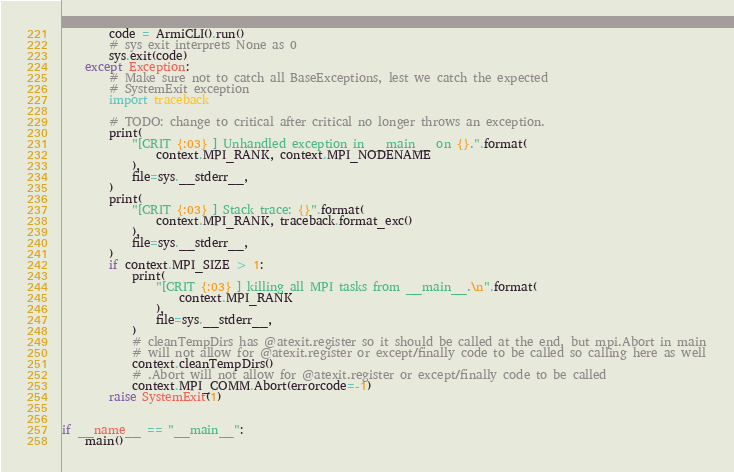<code> <loc_0><loc_0><loc_500><loc_500><_Python_>        code = ArmiCLI().run()
        # sys exit interprets None as 0
        sys.exit(code)
    except Exception:
        # Make sure not to catch all BaseExceptions, lest we catch the expected
        # SystemExit exception
        import traceback

        # TODO: change to critical after critical no longer throws an exception.
        print(
            "[CRIT {:03} ] Unhandled exception in __main__ on {}.".format(
                context.MPI_RANK, context.MPI_NODENAME
            ),
            file=sys.__stderr__,
        )
        print(
            "[CRIT {:03} ] Stack trace: {}".format(
                context.MPI_RANK, traceback.format_exc()
            ),
            file=sys.__stderr__,
        )
        if context.MPI_SIZE > 1:
            print(
                "[CRIT {:03} ] killing all MPI tasks from __main__.\n".format(
                    context.MPI_RANK
                ),
                file=sys.__stderr__,
            )
            # cleanTempDirs has @atexit.register so it should be called at the end, but mpi.Abort in main
            # will not allow for @atexit.register or except/finally code to be called so calling here as well
            context.cleanTempDirs()
            # .Abort will not allow for @atexit.register or except/finally code to be called
            context.MPI_COMM.Abort(errorcode=-1)
        raise SystemExit(1)


if __name__ == "__main__":
    main()
</code> 